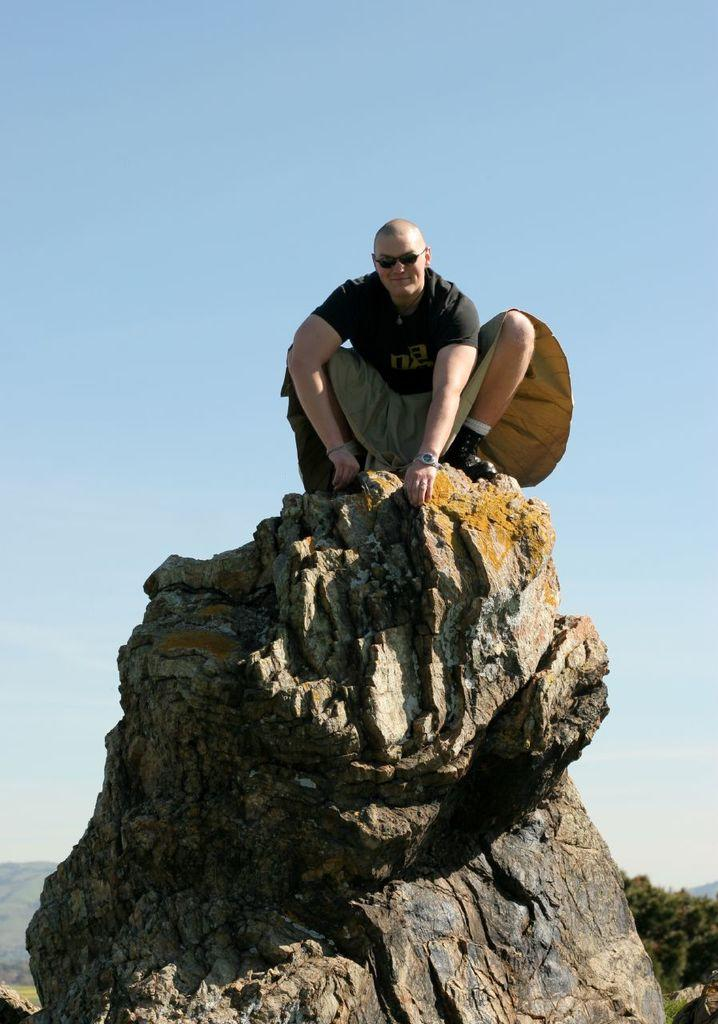What is the main subject of the image? There is a person in the image. What is the person wearing? The person is wearing goggles. Where is the person located in the image? The person is on a rock. What can be seen in the background of the image? There is sky visible in the background of the image. What is the writer's opinion on the person's choice of goggles in the image? There is no writer present in the image, and therefore no opinion can be attributed to them regarding the person's choice of goggles. 